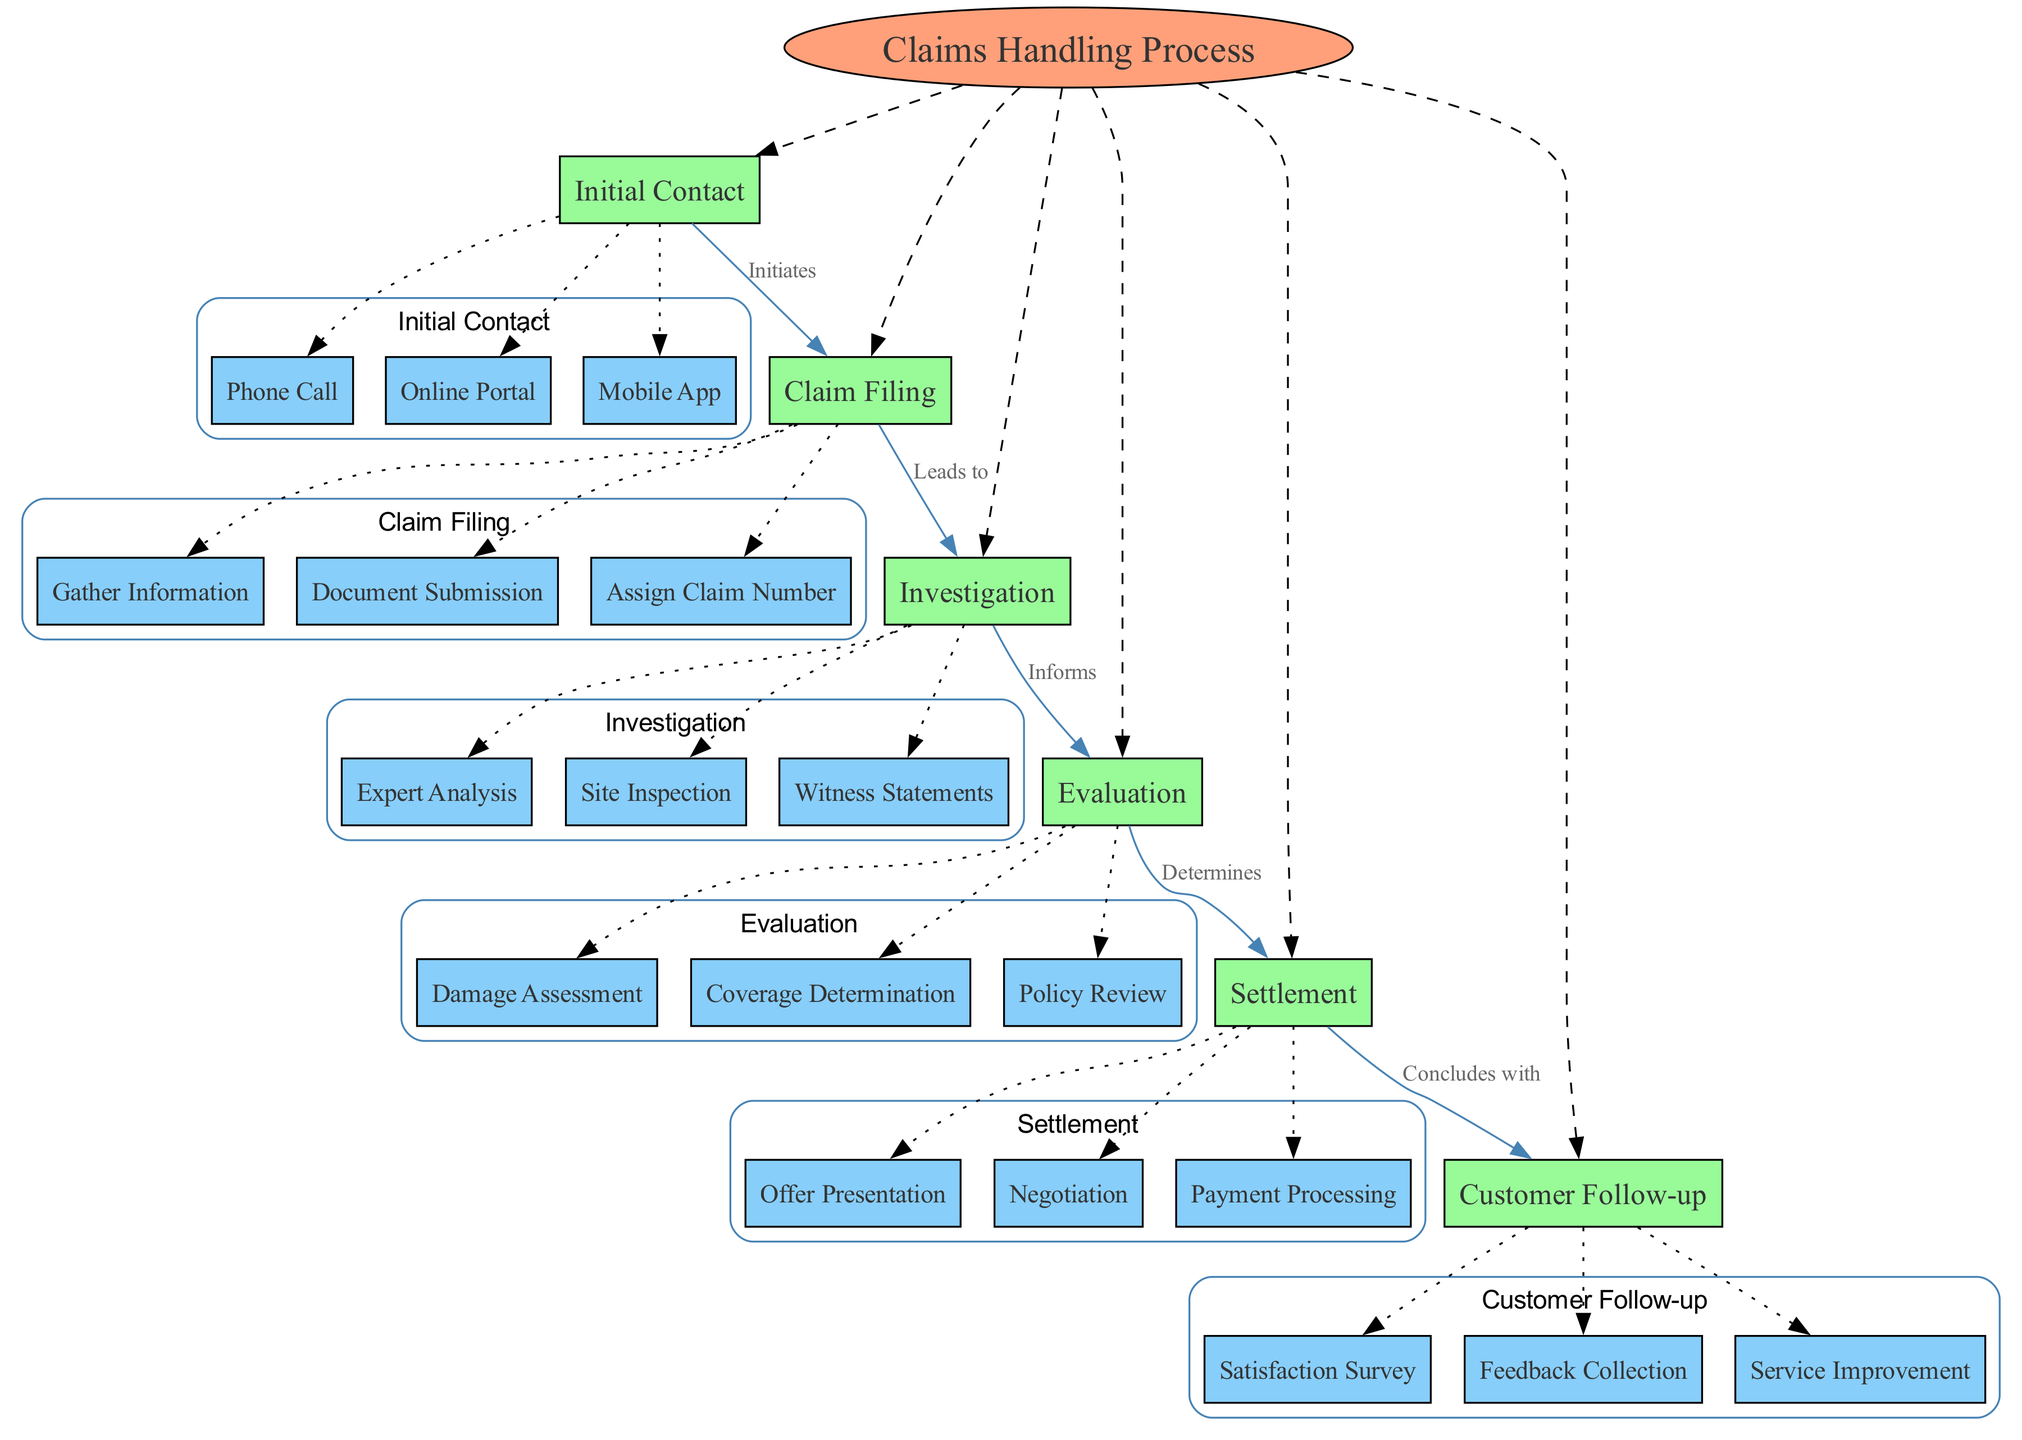What is the central concept of the diagram? The central concept is depicted at the top of the diagram and is labeled as "Claims Handling Process."
Answer: Claims Handling Process How many main nodes are there in the diagram? By counting the rectangles connected to the central concept, there are six main nodes: Initial Contact, Claim Filing, Investigation, Evaluation, Settlement, and Customer Follow-up.
Answer: 6 Which node is directly connected to "Settlement"? Following the connections on the diagram, the node that follows "Settlement" is "Customer Follow-up," indicating the process concludes with this step.
Answer: Customer Follow-up What is the relationship between "Claim Filing" and "Investigation"? The arrow from "Claim Filing" to "Investigation" is labeled as "Leads to," indicating that the Claim Filing step leads into the Investigation phase of the process.
Answer: Leads to Which method is used for Initial Contact in the claim handling process? The sub-nodes under "Initial Contact," such as Phone Call, Online Portal, and Mobile App, indicate these methods are available for initial engagement.
Answer: Phone Call, Online Portal, Mobile App What is the last step in the claims handling process? The diagram shows that after the "Settlement" node, the process concludes with "Customer Follow-up," highlighting it as the final stage of the claims handling process.
Answer: Customer Follow-up How does "Investigation" inform the "Evaluation"? The connection is indicated by the label "Informs," meaning that the findings from the Investigation step provide necessary information that guides the Evaluation process.
Answer: Informs Which sub-node represents the action of gathering information in Claim Filing? Within the Claim Filing main node, the sub-node labeled "Gather Information" specifically identifies this action as part of the claim filing procedure.
Answer: Gather Information What node comes before "Evaluation" in the claims handling sequence? As per the diagram's connections, "Investigation" directly precedes "Evaluation," forming a sequential relationship in the claims process.
Answer: Investigation 